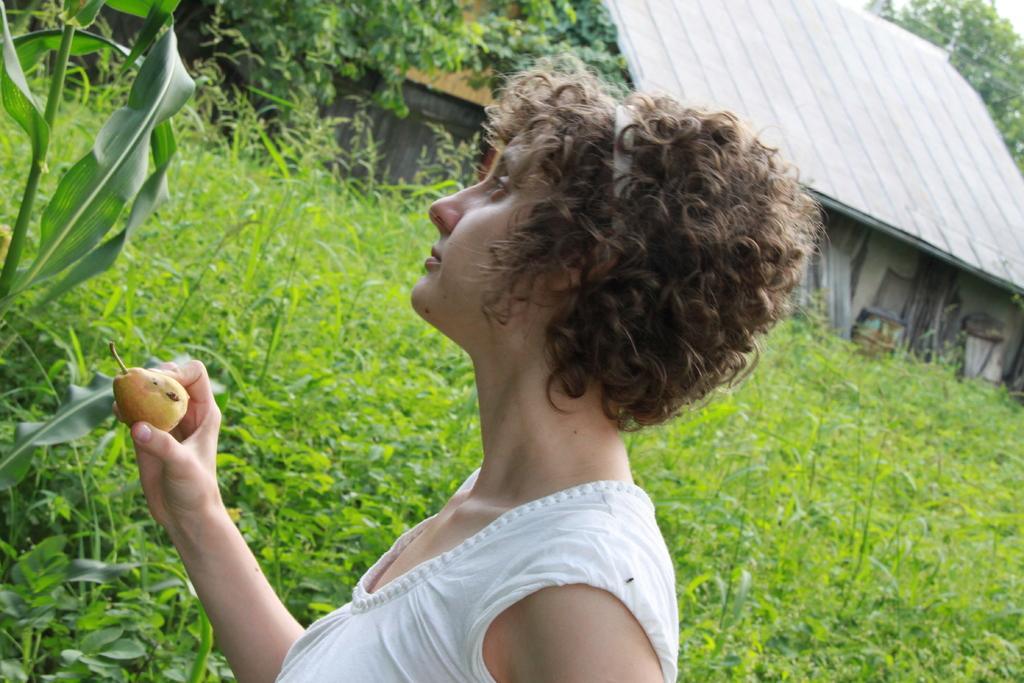How would you summarize this image in a sentence or two? In the middle of the image a woman is standing and holding a fruit. Beside her there are some plants and trees and shed. 